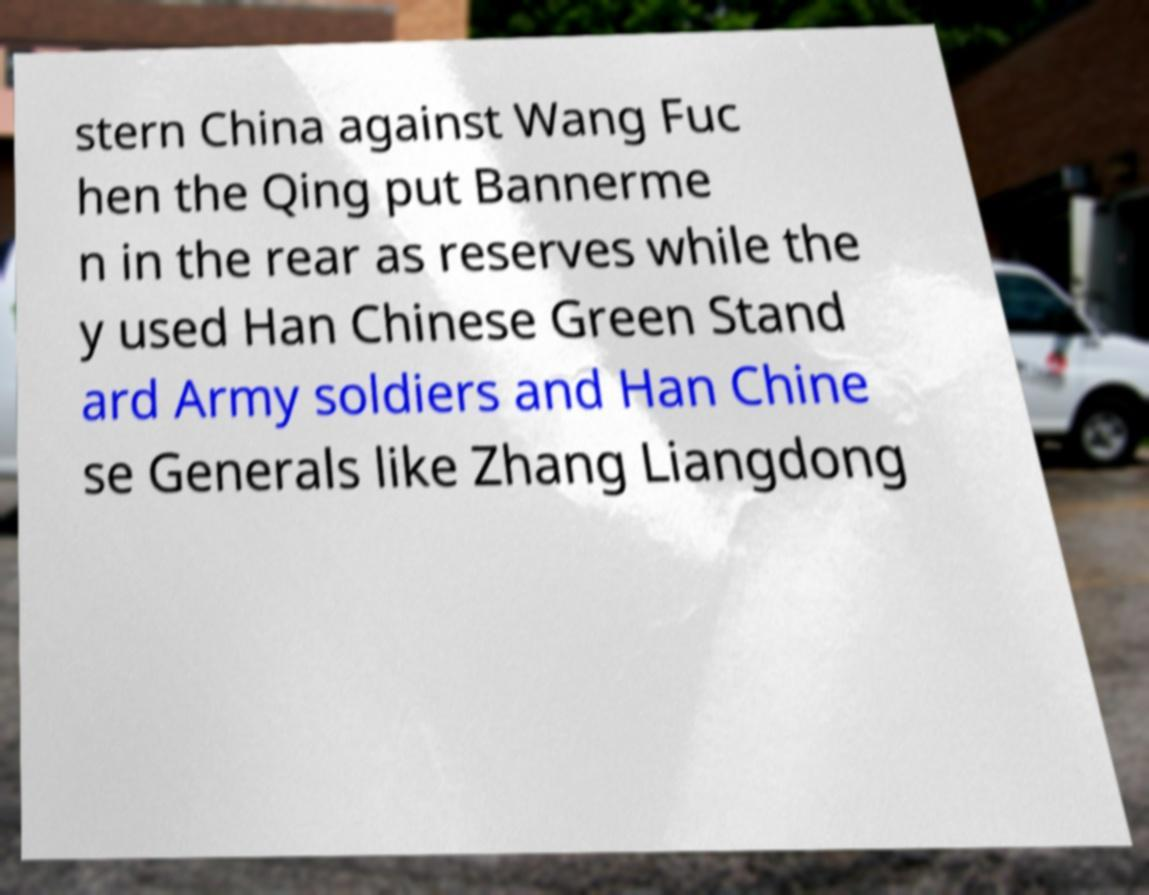Could you assist in decoding the text presented in this image and type it out clearly? stern China against Wang Fuc hen the Qing put Bannerme n in the rear as reserves while the y used Han Chinese Green Stand ard Army soldiers and Han Chine se Generals like Zhang Liangdong 